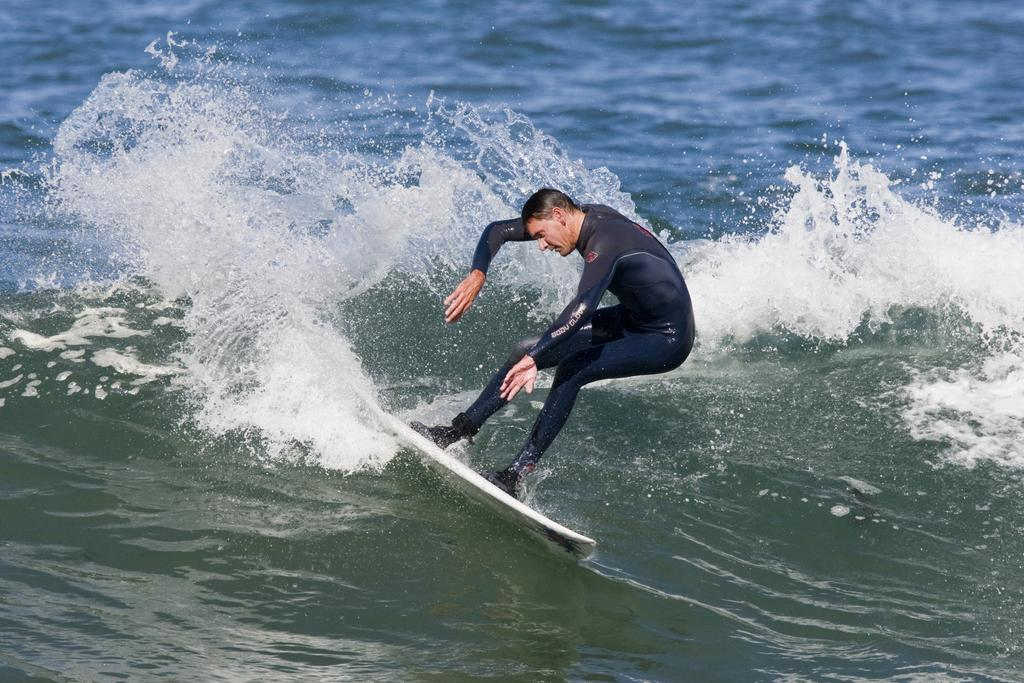What is the person in the image doing? The person is surfboarding. Where is the person located while performing this activity? The person is in the water. What type of shock can be seen affecting the person while surfboarding in the image? There is no shock present in the image; the person is simply surfboarding in the water. What type of plate is being used by the person while surfboarding in the image? There is no plate present in the image, as the person is surfboarding in the water. 